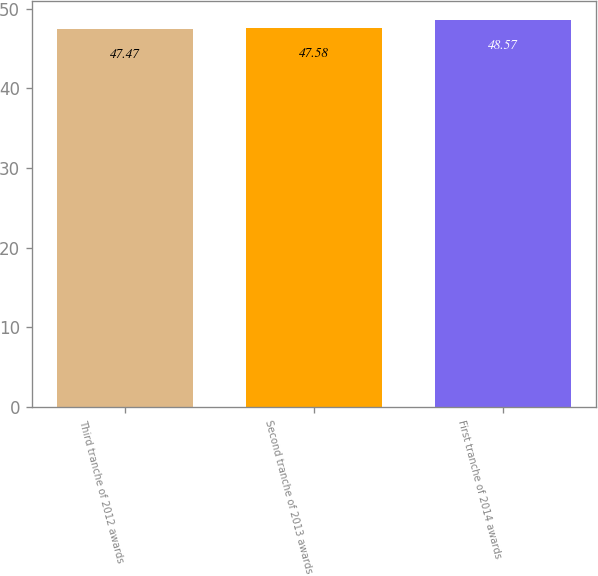Convert chart. <chart><loc_0><loc_0><loc_500><loc_500><bar_chart><fcel>Third tranche of 2012 awards<fcel>Second tranche of 2013 awards<fcel>First tranche of 2014 awards<nl><fcel>47.47<fcel>47.58<fcel>48.57<nl></chart> 